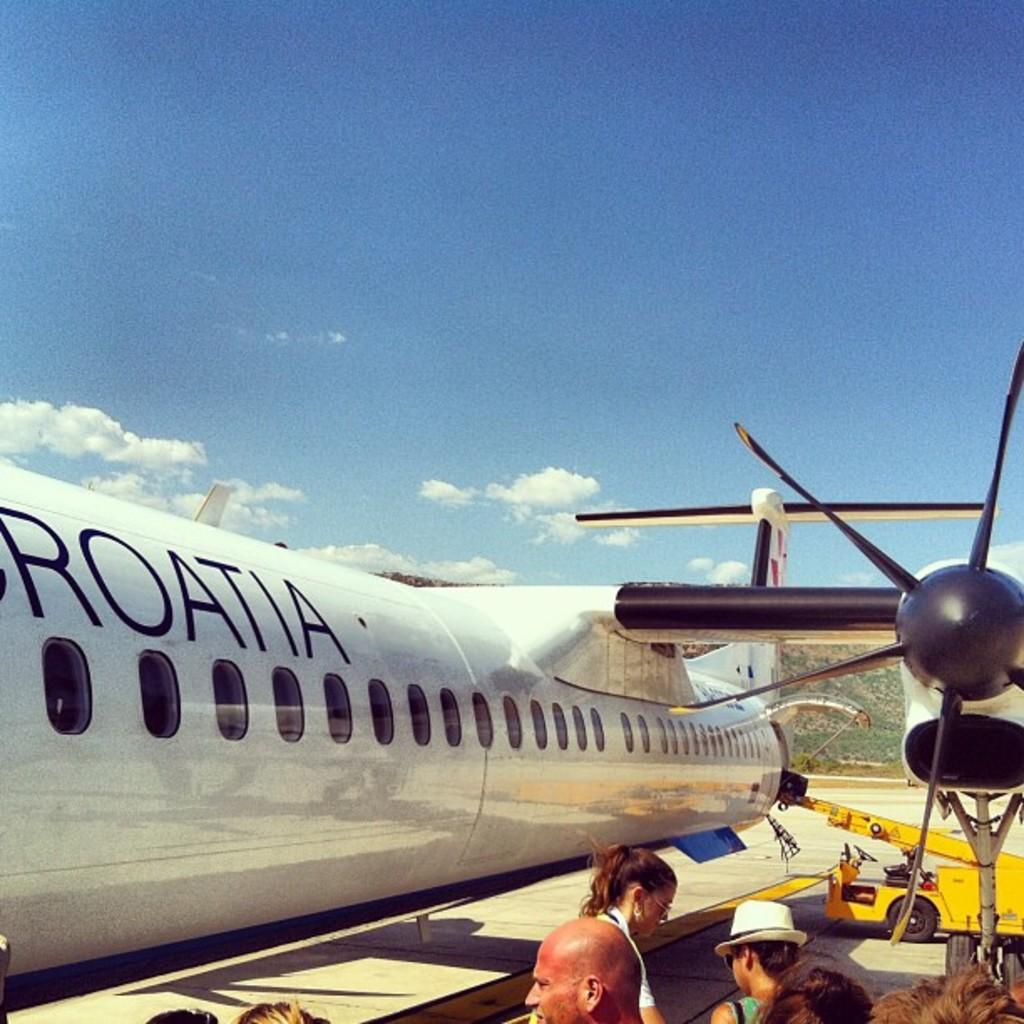<image>
Offer a succinct explanation of the picture presented. A white airplane with the words Croatia written on the side 